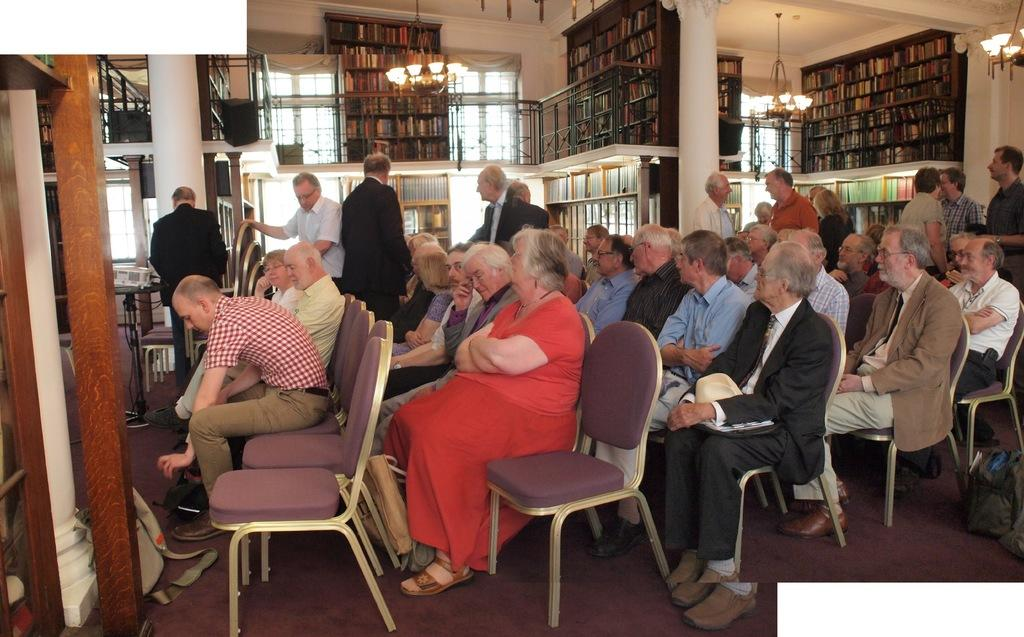What are the people in the image doing? There are people sitting on chairs and standing in the image. Can you describe the setting in which the people are located? The people are in a room with bookshelves visible in the background. What type of match is being played in the image? There is no match being played in the image; it does not depict any sports or games. 